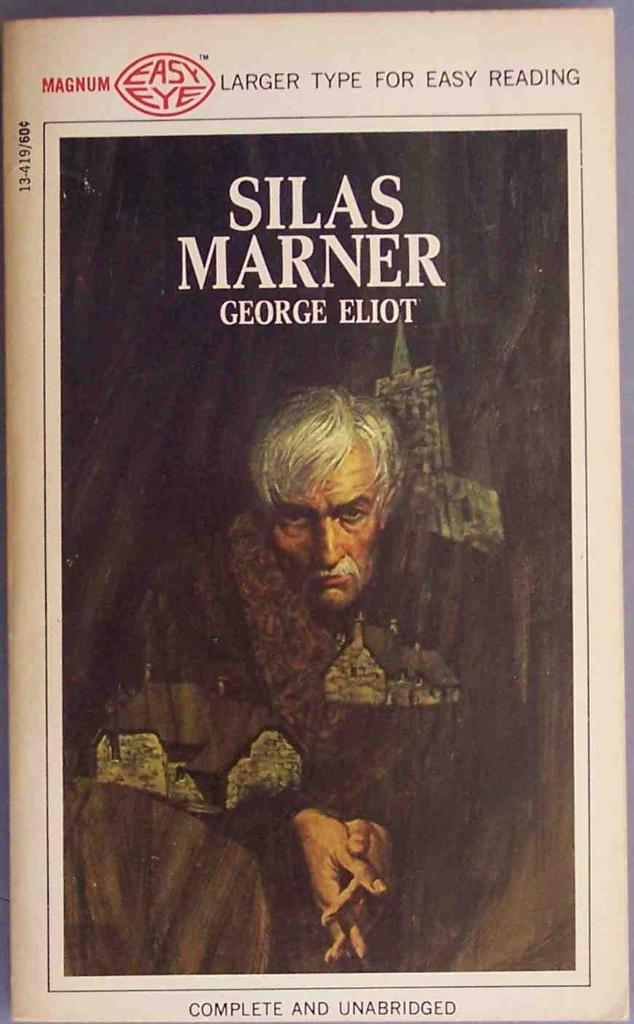<image>
Summarize the visual content of the image. A book has a large type and is written by George Eliot. 